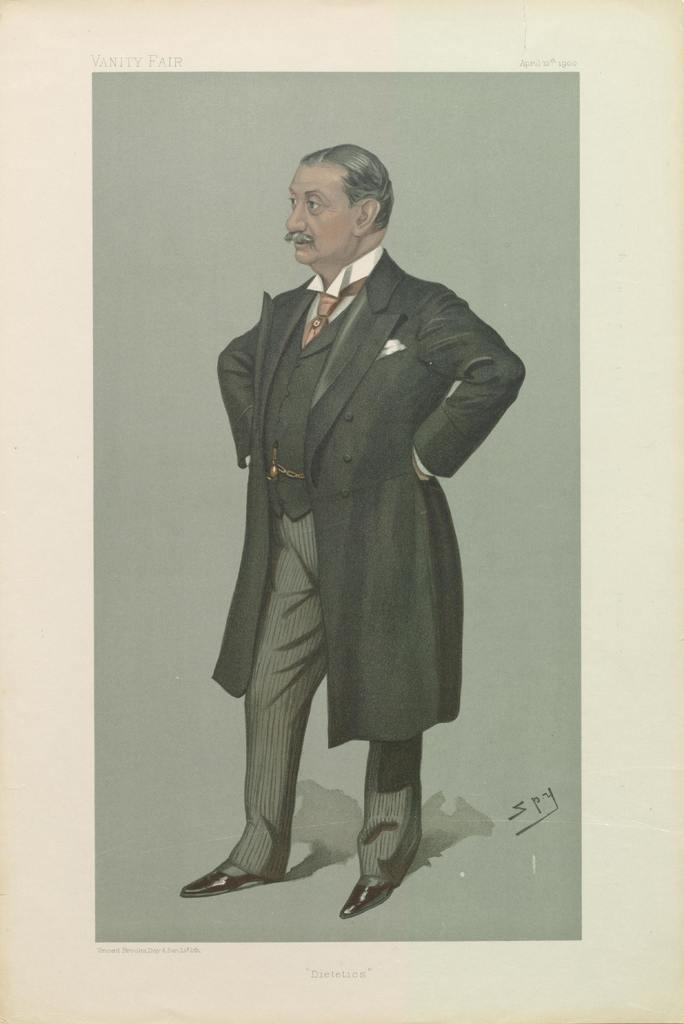What is the main subject of the image? There is a painting in the image. What is the painting depicting? The painting depicts a man standing. What historical event is being depicted in the painting? The provided facts do not mention any historical event, and the painting only depicts a man standing. 